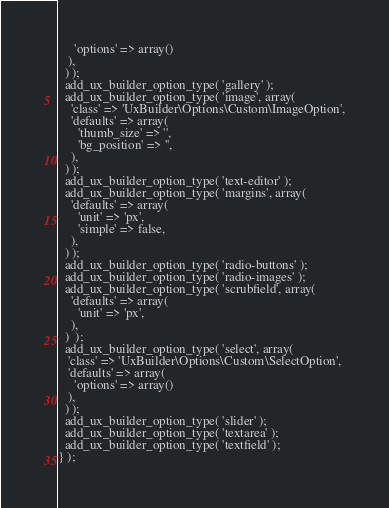Convert code to text. <code><loc_0><loc_0><loc_500><loc_500><_PHP_>     'options' => array()
   ),
  ) );
  add_ux_builder_option_type( 'gallery' );
  add_ux_builder_option_type( 'image', array(
    'class' => 'UxBuilder\Options\Custom\ImageOption',
    'defaults' => array(
      'thumb_size' => '',
      'bg_position' => '',
    ),
  ) );
  add_ux_builder_option_type( 'text-editor' );
  add_ux_builder_option_type( 'margins', array(
    'defaults' => array(
      'unit' => 'px',
      'simple' => false,
    ),
  ) );
  add_ux_builder_option_type( 'radio-buttons' );
  add_ux_builder_option_type( 'radio-images' );
  add_ux_builder_option_type( 'scrubfield', array(
    'defaults' => array(
      'unit' => 'px',
    ),
  )  );
  add_ux_builder_option_type( 'select', array(
   'class' => 'UxBuilder\Options\Custom\SelectOption',
   'defaults' => array(
     'options' => array()
   ),
  ) );
  add_ux_builder_option_type( 'slider' );
  add_ux_builder_option_type( 'textarea' );
  add_ux_builder_option_type( 'textfield' );
} );
</code> 